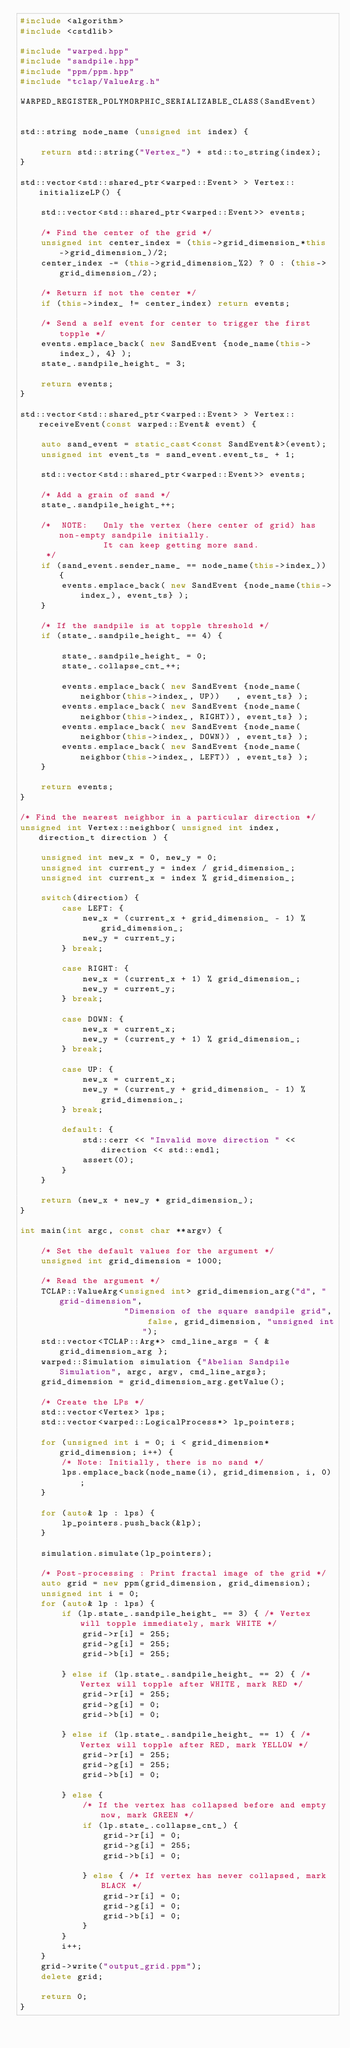Convert code to text. <code><loc_0><loc_0><loc_500><loc_500><_C++_>#include <algorithm>
#include <cstdlib>

#include "warped.hpp"
#include "sandpile.hpp"
#include "ppm/ppm.hpp"
#include "tclap/ValueArg.h"

WARPED_REGISTER_POLYMORPHIC_SERIALIZABLE_CLASS(SandEvent)


std::string node_name (unsigned int index) {

    return std::string("Vertex_") + std::to_string(index);
}

std::vector<std::shared_ptr<warped::Event> > Vertex::initializeLP() {

    std::vector<std::shared_ptr<warped::Event>> events;

    /* Find the center of the grid */
    unsigned int center_index = (this->grid_dimension_*this->grid_dimension_)/2;
    center_index -= (this->grid_dimension_%2) ? 0 : (this->grid_dimension_/2);

    /* Return if not the center */
    if (this->index_ != center_index) return events;

    /* Send a self event for center to trigger the first topple */
    events.emplace_back( new SandEvent {node_name(this->index_), 4} );
    state_.sandpile_height_ = 3;

    return events;
}

std::vector<std::shared_ptr<warped::Event> > Vertex::receiveEvent(const warped::Event& event) {

    auto sand_event = static_cast<const SandEvent&>(event);
    unsigned int event_ts = sand_event.event_ts_ + 1;

    std::vector<std::shared_ptr<warped::Event>> events;

    /* Add a grain of sand */
    state_.sandpile_height_++;

    /*  NOTE:   Only the vertex (here center of grid) has non-empty sandpile initially.
                It can keep getting more sand.
     */
    if (sand_event.sender_name_ == node_name(this->index_)) {
        events.emplace_back( new SandEvent {node_name(this->index_), event_ts} );
    }

    /* If the sandpile is at topple threshold */
    if (state_.sandpile_height_ == 4) {

        state_.sandpile_height_ = 0;
        state_.collapse_cnt_++;

        events.emplace_back( new SandEvent {node_name(neighbor(this->index_, UP))   , event_ts} );
        events.emplace_back( new SandEvent {node_name(neighbor(this->index_, RIGHT)), event_ts} );
        events.emplace_back( new SandEvent {node_name(neighbor(this->index_, DOWN)) , event_ts} );
        events.emplace_back( new SandEvent {node_name(neighbor(this->index_, LEFT)) , event_ts} );
    }

    return events;
}

/* Find the nearest neighbor in a particular direction */
unsigned int Vertex::neighbor( unsigned int index, direction_t direction ) {

    unsigned int new_x = 0, new_y = 0;
    unsigned int current_y = index / grid_dimension_;
    unsigned int current_x = index % grid_dimension_;

    switch(direction) {
        case LEFT: {
            new_x = (current_x + grid_dimension_ - 1) % grid_dimension_;
            new_y = current_y;
        } break;

        case RIGHT: {
            new_x = (current_x + 1) % grid_dimension_;
            new_y = current_y;
        } break;

        case DOWN: {
            new_x = current_x;
            new_y = (current_y + 1) % grid_dimension_;
        } break;

        case UP: {
            new_x = current_x;
            new_y = (current_y + grid_dimension_ - 1) % grid_dimension_;
        } break;

        default: {
            std::cerr << "Invalid move direction " << direction << std::endl;
            assert(0);
        }
    }

    return (new_x + new_y * grid_dimension_);
}

int main(int argc, const char **argv) {

    /* Set the default values for the argument */
    unsigned int grid_dimension = 1000;

    /* Read the argument */
    TCLAP::ValueArg<unsigned int> grid_dimension_arg("d", "grid-dimension",
                    "Dimension of the square sandpile grid", false, grid_dimension, "unsigned int");
    std::vector<TCLAP::Arg*> cmd_line_args = { &grid_dimension_arg };
    warped::Simulation simulation {"Abelian Sandpile Simulation", argc, argv, cmd_line_args};
    grid_dimension = grid_dimension_arg.getValue();

    /* Create the LPs */
    std::vector<Vertex> lps;
    std::vector<warped::LogicalProcess*> lp_pointers;

    for (unsigned int i = 0; i < grid_dimension*grid_dimension; i++) {
        /* Note: Initially, there is no sand */
        lps.emplace_back(node_name(i), grid_dimension, i, 0);
    }

    for (auto& lp : lps) {
        lp_pointers.push_back(&lp);
    }

    simulation.simulate(lp_pointers);

    /* Post-processing : Print fractal image of the grid */
    auto grid = new ppm(grid_dimension, grid_dimension);
    unsigned int i = 0;
    for (auto& lp : lps) {
        if (lp.state_.sandpile_height_ == 3) { /* Vertex will topple immediately, mark WHITE */
            grid->r[i] = 255;
            grid->g[i] = 255;
            grid->b[i] = 255;

        } else if (lp.state_.sandpile_height_ == 2) { /* Vertex will topple after WHITE, mark RED */
            grid->r[i] = 255;
            grid->g[i] = 0;
            grid->b[i] = 0;

        } else if (lp.state_.sandpile_height_ == 1) { /* Vertex will topple after RED, mark YELLOW */
            grid->r[i] = 255;
            grid->g[i] = 255;
            grid->b[i] = 0;

        } else {
            /* If the vertex has collapsed before and empty now, mark GREEN */
            if (lp.state_.collapse_cnt_) {
                grid->r[i] = 0;
                grid->g[i] = 255;
                grid->b[i] = 0;

            } else { /* If vertex has never collapsed, mark BLACK */
                grid->r[i] = 0;
                grid->g[i] = 0;
                grid->b[i] = 0;
            }
        }
        i++;
    }
    grid->write("output_grid.ppm");
    delete grid;

    return 0;
}

</code> 